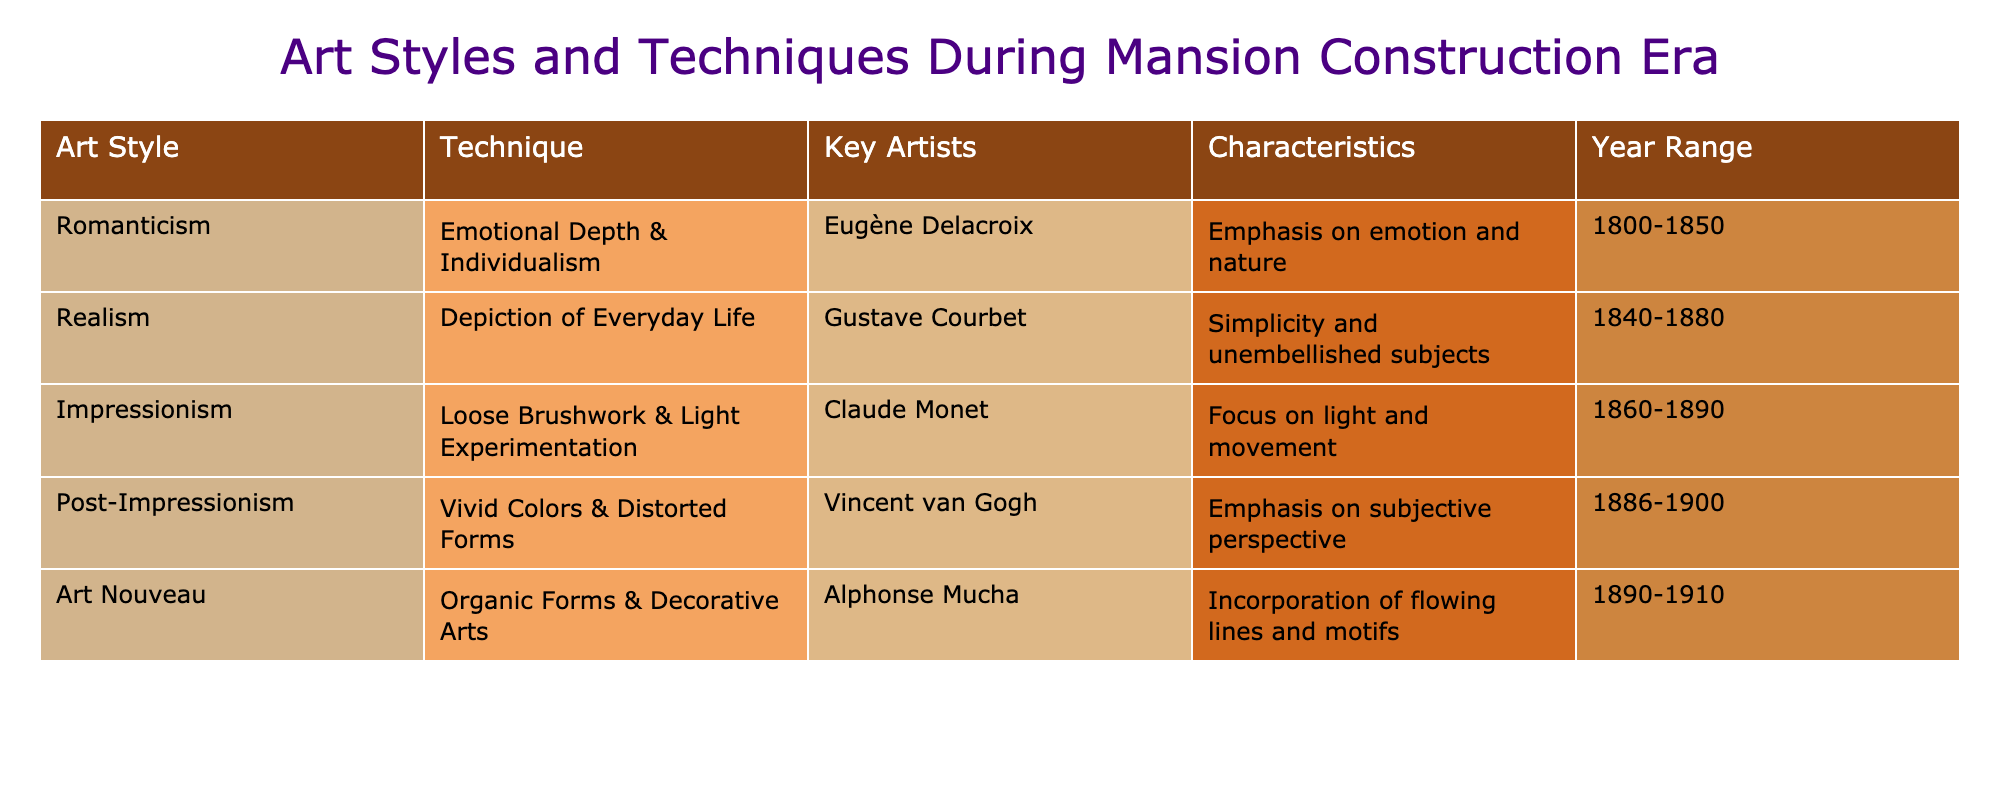What is the key artist associated with Impressionism? The table lists Claude Monet as the key artist under the Impressionism category. This can be found directly in the "Key Artists" column corresponding to the "Impressionism" art style.
Answer: Claude Monet Which art style emphasizes emotional depth and individualism? The table shows that Romanticism emphasizes emotional depth and individualism. This is found by looking at the "Art Style" and "Characteristics" columns where Romanticism's characteristics are described.
Answer: Romanticism Is there an art style that incorporates flowing lines and motifs? Yes, the table indicates Art Nouveau as the art style that incorporates flowing lines and motifs, mentioned under the "Characteristics" column for Art Nouveau.
Answer: Yes What art style was prevalent from 1860 to 1890? The table shows that Impressionism was prevalent during the year range of 1860 to 1890, as indicated in the "Year Range" column.
Answer: Impressionism If we consider the year ranges for Realism and Post-Impressionism, which one has a longer duration? Realism spans from 1840 to 1880 (40 years), while Post-Impressionism spans from 1886 to 1900 (14 years). By comparing the two durations (1880 - 1840 = 40 years and 1900 - 1886 = 14 years), Realism has the longer duration.
Answer: Realism Which art style is characterized by a focus on light and movement? The table shows that Impressionism is characterized by a focus on light and movement, as noted in the "Characteristics" column.
Answer: Impressionism Are there any art styles listed that coincide with the late 19th century? Yes, both Impressionism (1860-1890) and Art Nouveau (1890-1910) coincide with the late 19th century based on their year ranges found in the "Year Range" column.
Answer: Yes What is the difference in the year range between Romanticism and Realism? Romanticism ranges from 1800 to 1850 (50 years), while Realism ranges from 1840 to 1880 (40 years). To find the difference, calculate: 50 - 40 = 10 years. Therefore, the difference is 10 years.
Answer: 10 years Which art style is noted for its emphasis on subjective perspective? The table indicates that Post-Impressionism is noted for its emphasis on subjective perspective as outlined in the "Characteristics" column.
Answer: Post-Impressionism 